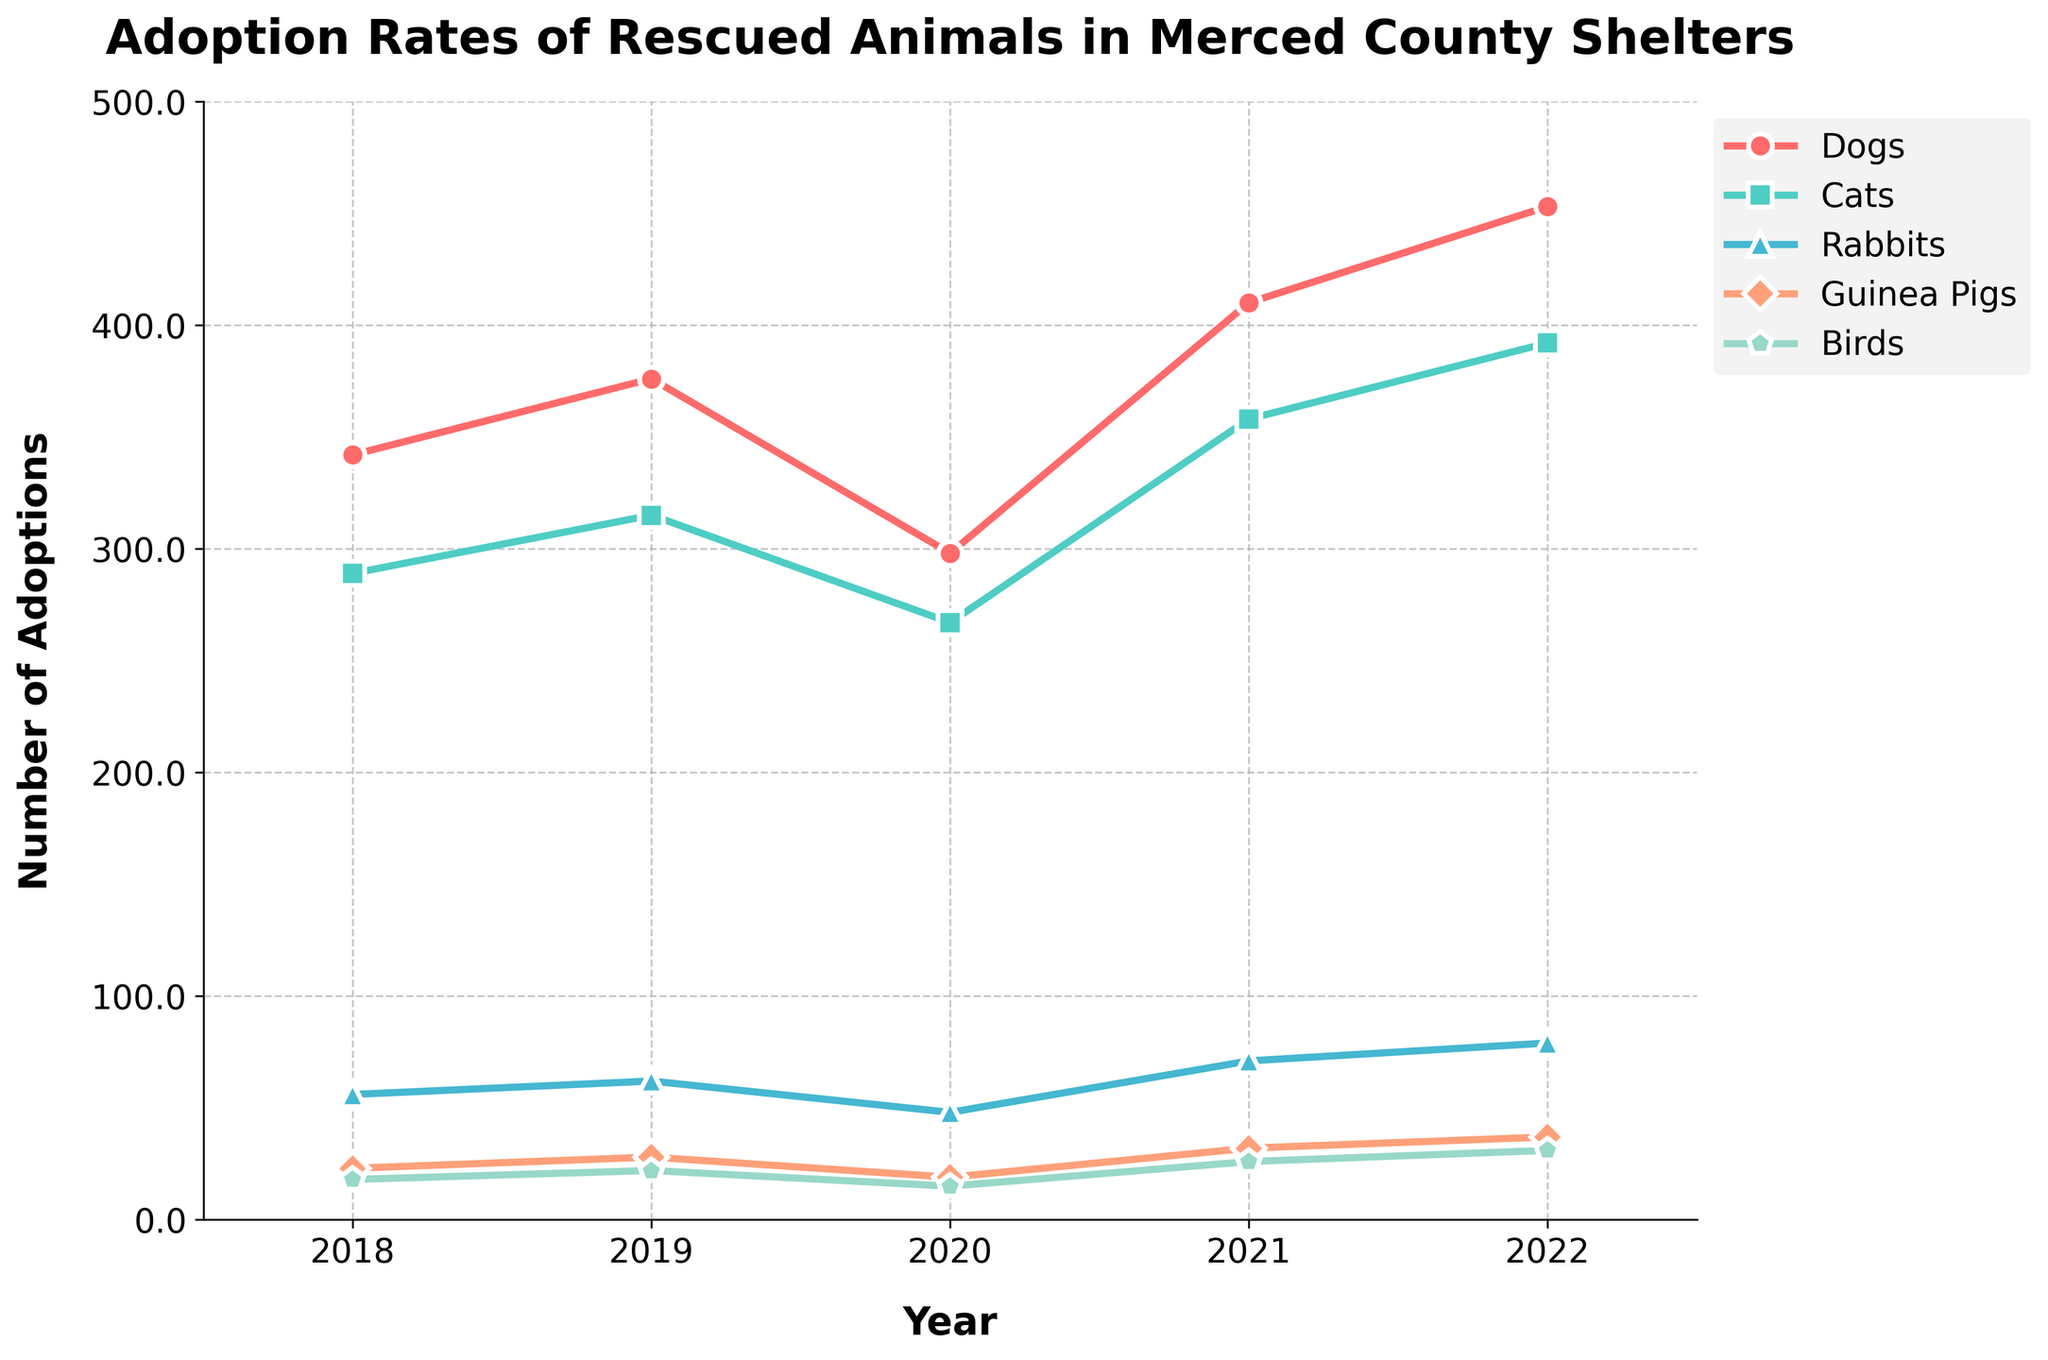How did adoptions for dogs change from 2018 to 2022? Adoptions for dogs increased from 342 in 2018 to 453 in 2022. Observing the "Dogs" line, the values at 2018 and 2022 are 342 and 453 respectively.
Answer: From 342 to 453 Did cat adoptions increase or decrease from 2019 to 2020? Cat adoptions decreased from 315 in 2019 to 267 in 2020. The "Cats" line shows a drop between these years with values 315 and 267.
Answer: Decrease How many total adoptions were there for rabbits in 2021 and 2022? To find the total adoptions for rabbits in 2021 and 2022, add the values for these years: 71 + 79 = 150. The "Rabbits" line has values of 71 (2021) and 79 (2022).
Answer: 150 Which year and animal type had the lowest adoption rates in the dataset? The lowest adoption rate in the dataset is for birds in 2020 with 15 adoptions. Comparing all lines, the lowest point is at "Birds" in 2020 with the value 15.
Answer: Birds in 2020 How many more adoptions were there for guinea pigs in 2022 compared to 2018? The adoptions for guinea pigs in 2022 were 37, and in 2018 they were 23. So, the difference is 37 - 23 = 14. The "Guinea Pigs" line at 2018 is 23 and at 2022 is 37.
Answer: 14 more Which animal had the most significant increase in adoptions from 2020 to 2021? Rabbits had the most significant increase, from 48 in 2020 to 71 in 2021. This increase is 23. Calculating the differences for each animal type, rabbits have the highest increase (71 - 48).
Answer: Rabbits Which animal type consistently increased in adoption numbers every year? Dogs consistently increased from 2018 to 2022 each year. By observing the "Dogs" line, it shows a continuous upward trend without any decline across years.
Answer: Dogs Between which two consecutive years did bird adoptions increase the most? Bird adoptions increased the most between 2021 and 2022, from 26 to 31, a difference of 5. By examining the "Birds" line closely for year-to-year changes, the largest increment is between 2021 and 2022.
Answer: 2021 and 2022 How many fewer adoptions were there for cats in 2020 compared to 2021? Cat adoptions in 2020 were 267, and in 2021 they were 358. The difference is 358 - 267 = 91. The "Cats" line shows values of 267 (2020) and 358 (2021).
Answer: 91 fewer 